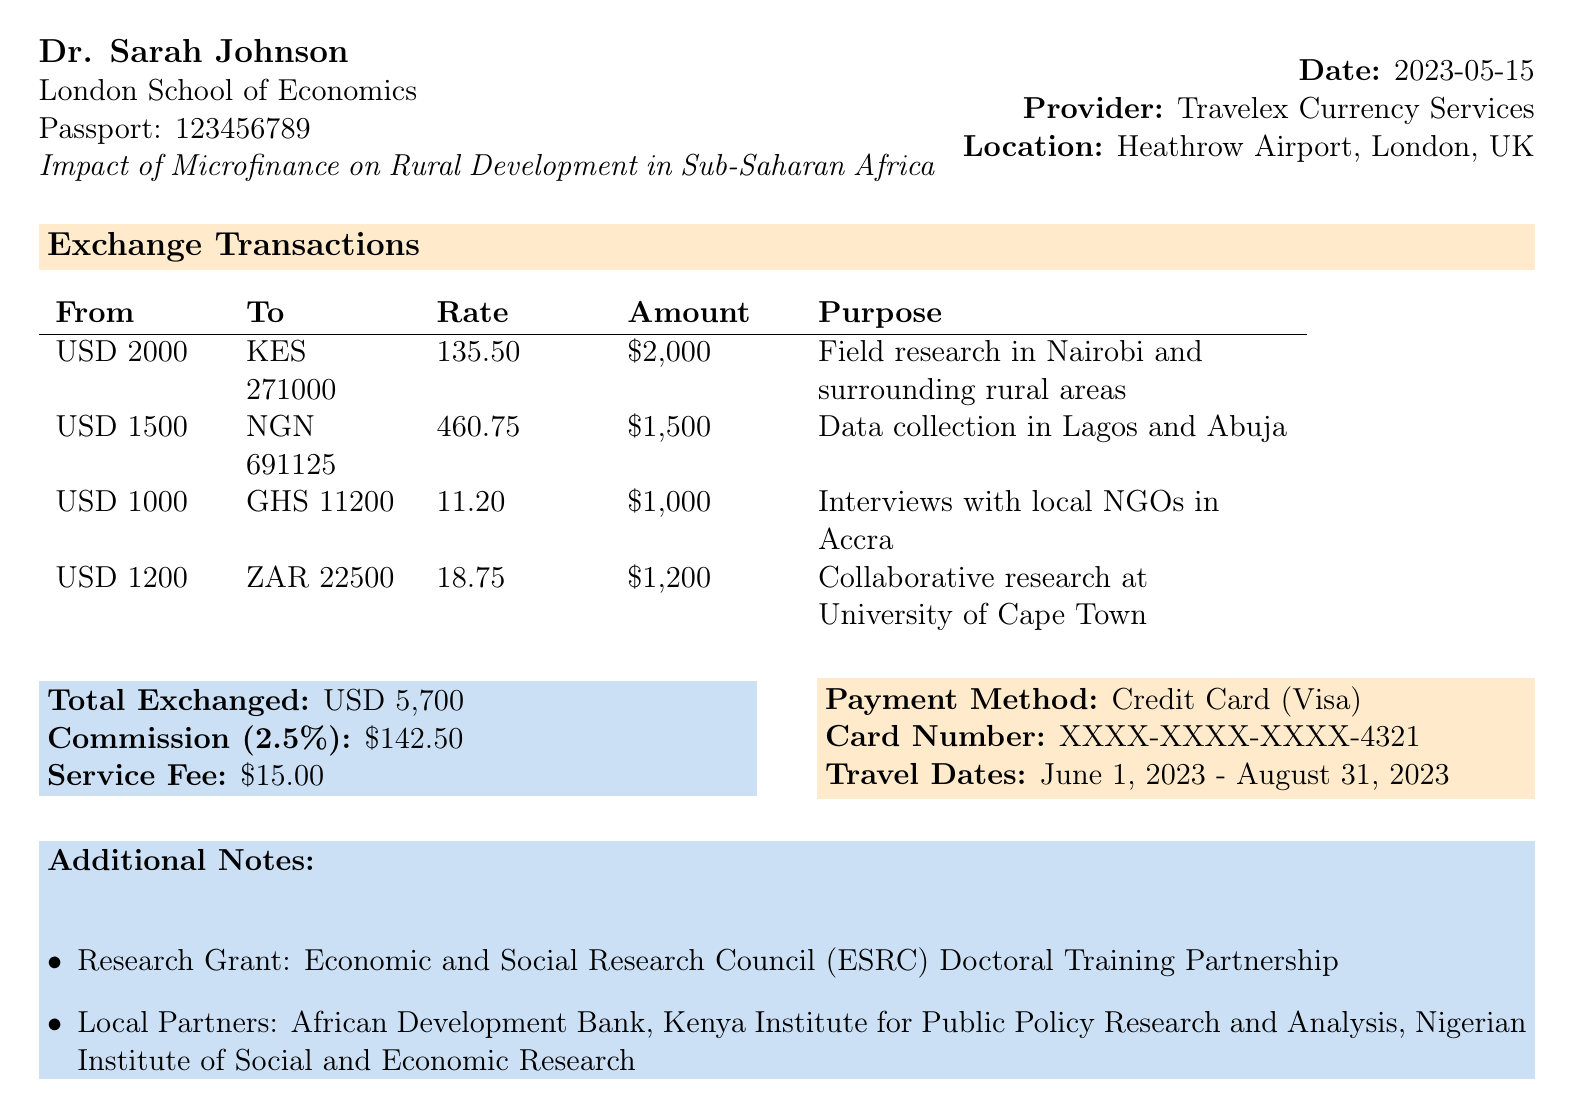What is the transaction ID? The transaction ID is a unique identifier used for the transaction specified in the document.
Answer: AFR-2023-06789 Who is the customer? The customer information includes the name of the person associated with the transaction, listed at the top of the document.
Answer: Dr. Sarah Johnson What is the total amount exchanged? The total amount exchanged is the sum of all currency exchange transactions listed in the document.
Answer: USD 5,700 What is the purpose of the exchange to Kenya? The purpose gives context for why the currency exchange is happening and indicates the specific location.
Answer: Field research in Nairobi and surrounding rural areas What is the commission rate charged? The commission rate provides information on the fees applied to the transaction, stated in percentage form.
Answer: 2.5% How many different currencies were exchanged? This involves counting the number of unique currency pairs in the exchange transactions section of the document.
Answer: 4 What is the service fee amount? The service fee is an additional cost applied independent of the exchange amount.
Answer: $15.00 What are the travel dates for the field research? The travel dates indicate the period during which the research activities are planned, mentioned in additional notes.
Answer: June 1, 2023 - August 31, 2023 Which institution is Dr. Sarah Johnson affiliated with? This identifies the organization associated with the customer in the document.
Answer: London School of Economics 